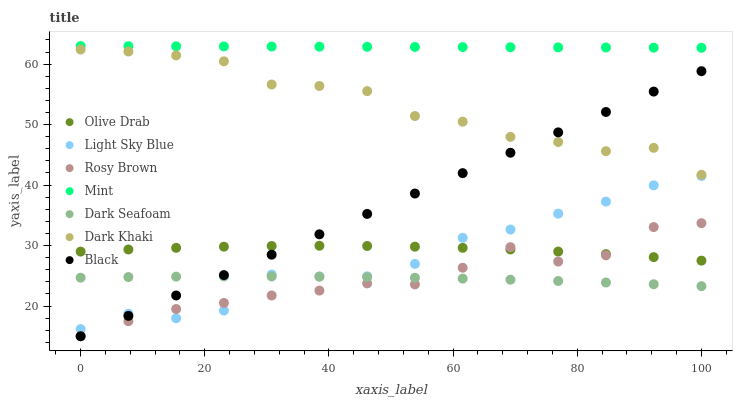Does Dark Seafoam have the minimum area under the curve?
Answer yes or no. Yes. Does Mint have the maximum area under the curve?
Answer yes or no. Yes. Does Dark Khaki have the minimum area under the curve?
Answer yes or no. No. Does Dark Khaki have the maximum area under the curve?
Answer yes or no. No. Is Black the smoothest?
Answer yes or no. Yes. Is Light Sky Blue the roughest?
Answer yes or no. Yes. Is Dark Khaki the smoothest?
Answer yes or no. No. Is Dark Khaki the roughest?
Answer yes or no. No. Does Rosy Brown have the lowest value?
Answer yes or no. Yes. Does Dark Khaki have the lowest value?
Answer yes or no. No. Does Mint have the highest value?
Answer yes or no. Yes. Does Dark Khaki have the highest value?
Answer yes or no. No. Is Dark Seafoam less than Mint?
Answer yes or no. Yes. Is Dark Khaki greater than Rosy Brown?
Answer yes or no. Yes. Does Dark Khaki intersect Black?
Answer yes or no. Yes. Is Dark Khaki less than Black?
Answer yes or no. No. Is Dark Khaki greater than Black?
Answer yes or no. No. Does Dark Seafoam intersect Mint?
Answer yes or no. No. 